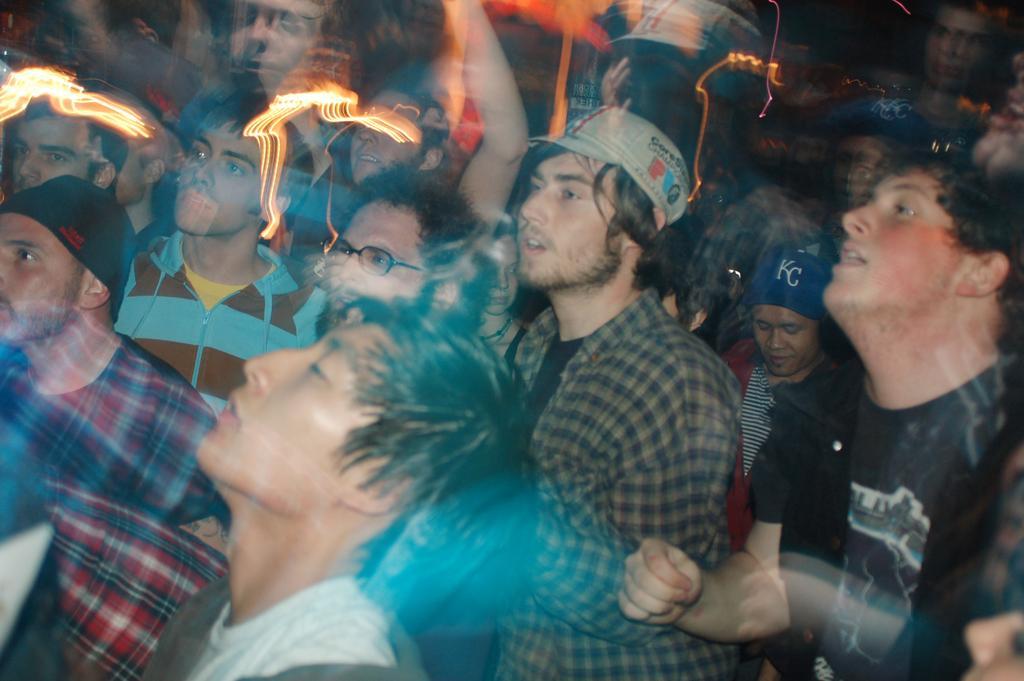Could you give a brief overview of what you see in this image? This is the image of a group of people, they look like lights on the left corner. 